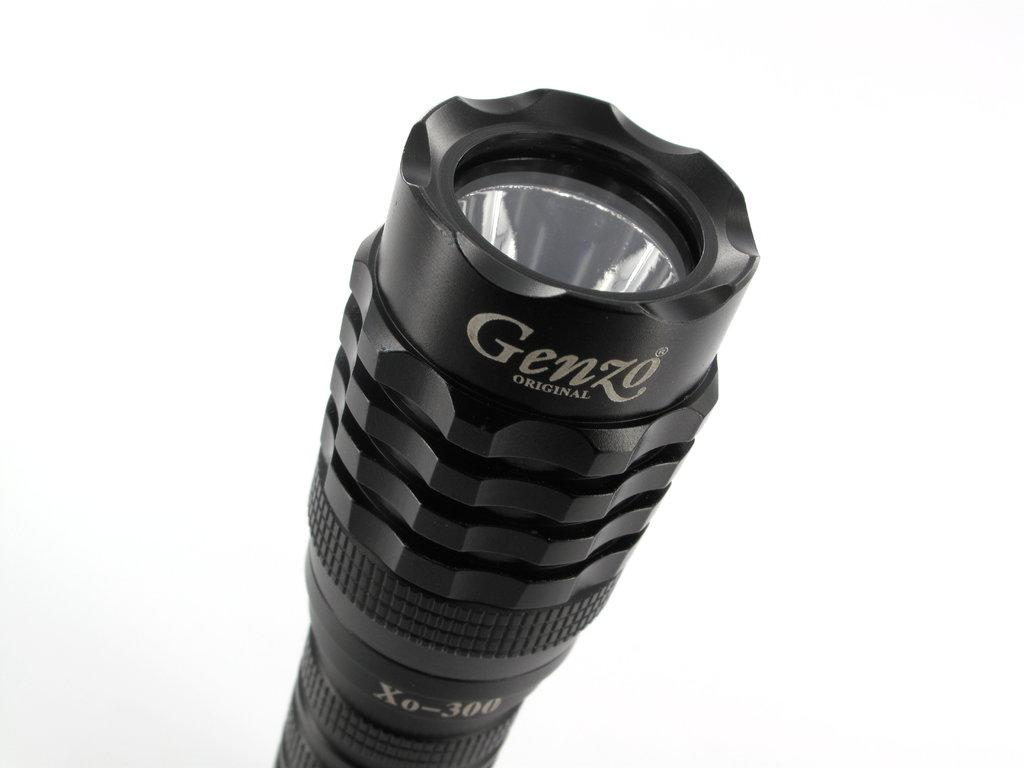What object is the main focus of the image? There is a torch light in the image. What is the color of the torch light? The torch light is black in color. Are there any words written on the torch light? Yes, the words "Genzo" are written on the torch light. What color is the background of the image? The background of the image is white in color. What type of apple is being eaten by the animal in the image? There is no apple or animal present in the image; it features a black torch light with the words "Genzo" on it against a white background. 